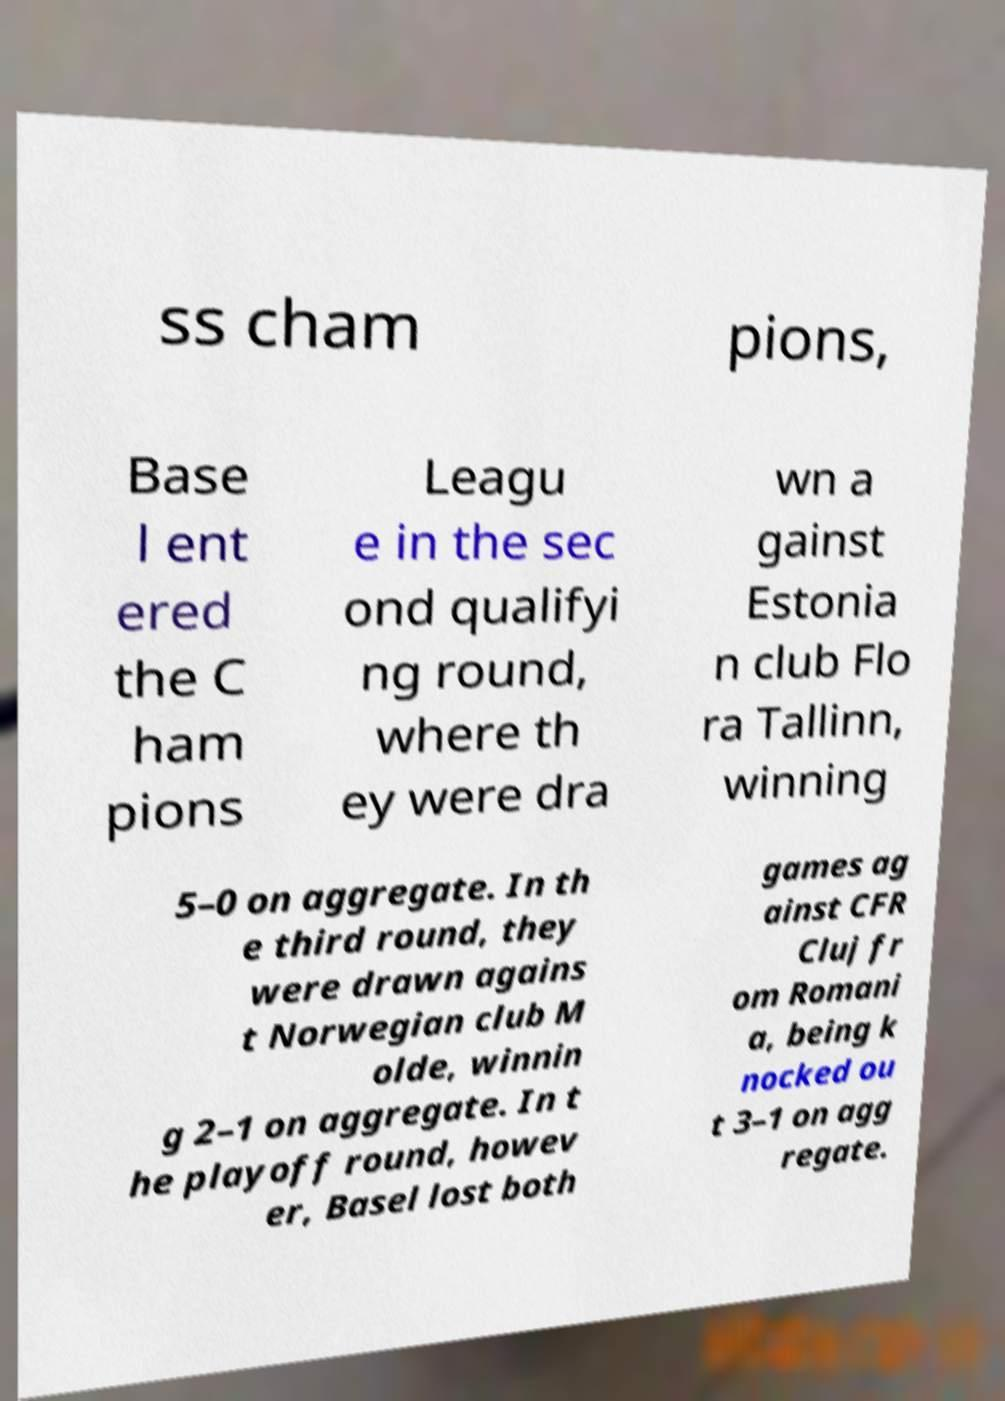Could you extract and type out the text from this image? ss cham pions, Base l ent ered the C ham pions Leagu e in the sec ond qualifyi ng round, where th ey were dra wn a gainst Estonia n club Flo ra Tallinn, winning 5–0 on aggregate. In th e third round, they were drawn agains t Norwegian club M olde, winnin g 2–1 on aggregate. In t he playoff round, howev er, Basel lost both games ag ainst CFR Cluj fr om Romani a, being k nocked ou t 3–1 on agg regate. 